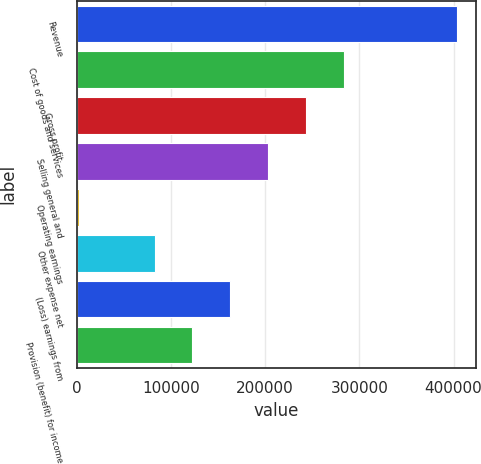Convert chart to OTSL. <chart><loc_0><loc_0><loc_500><loc_500><bar_chart><fcel>Revenue<fcel>Cost of goods and services<fcel>Gross profit<fcel>Selling general and<fcel>Operating earnings<fcel>Other expense net<fcel>(Loss) earnings from<fcel>Provision (benefit) for income<nl><fcel>403688<fcel>283248<fcel>243102<fcel>202955<fcel>2222<fcel>82515.2<fcel>162808<fcel>122662<nl></chart> 